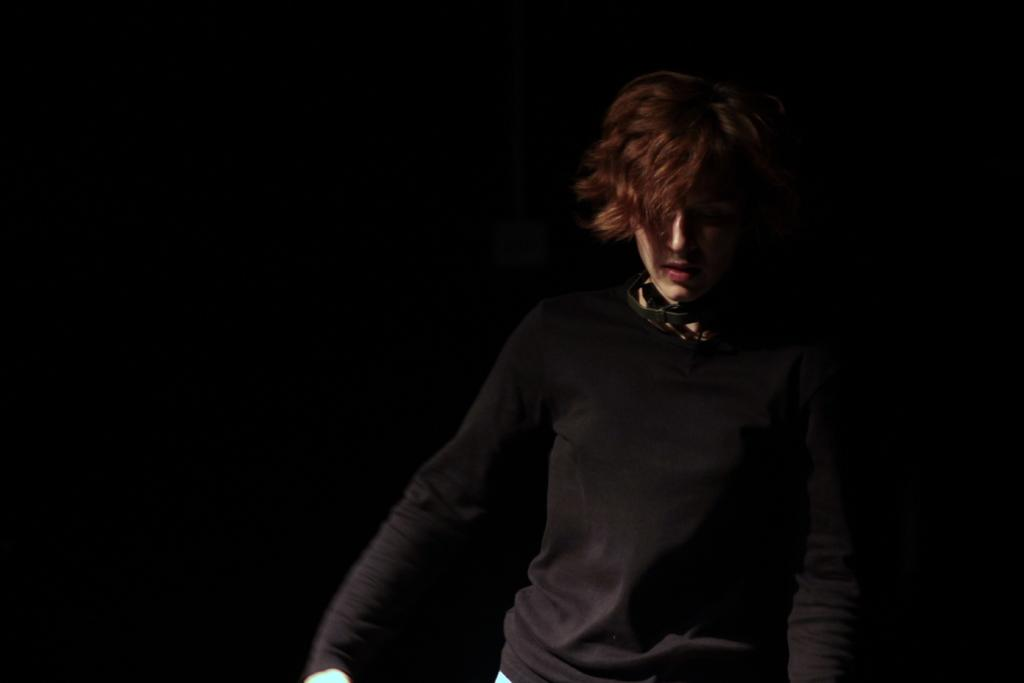Who or what is the main subject in the image? There is a person in the image. What is the person wearing? The person is wearing a black dress. Where is the person located in the image? The person is in the front of the image. What rule is being enforced by the person in the image? There is no indication in the image that the person is enforcing any rules. 